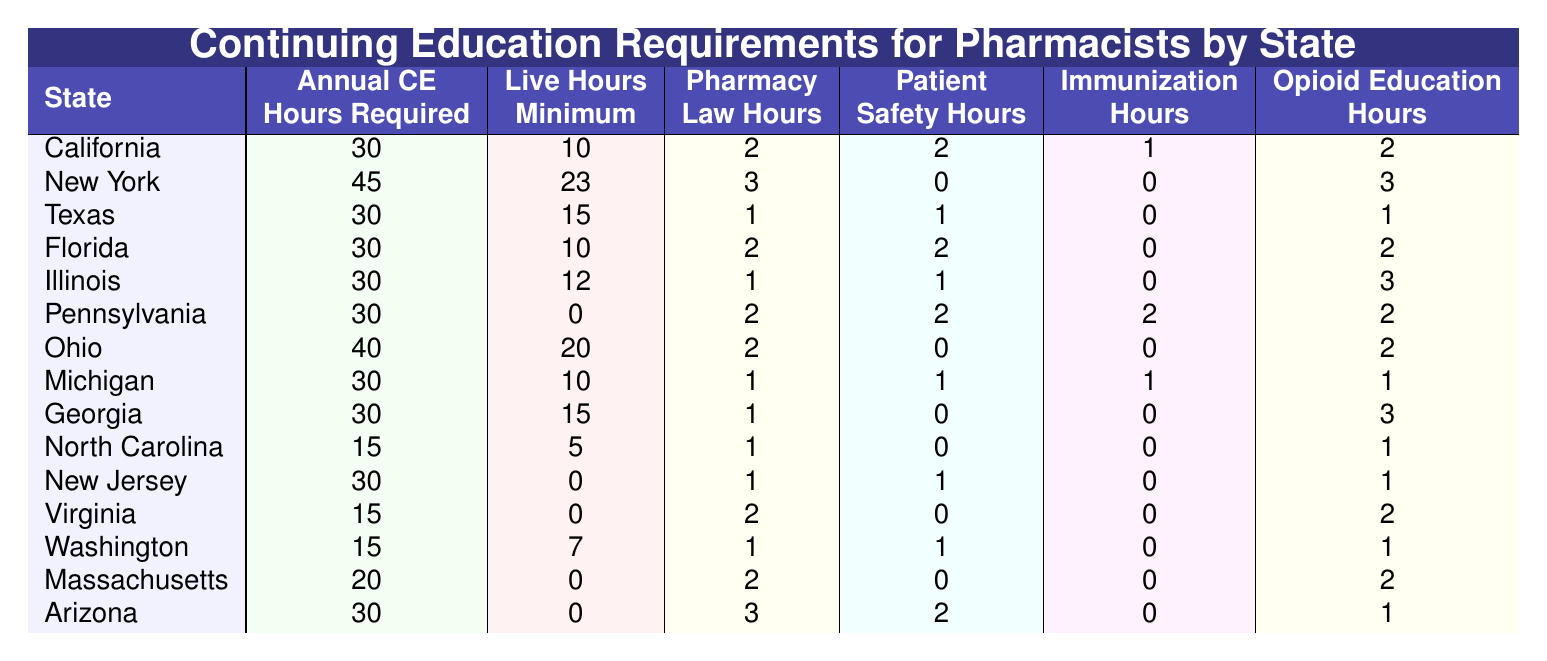What is the annual CE hours required for New York? The table shows that New York requires 45 annual CE hours.
Answer: 45 How many live hours are necessary for pharmacists in Texas? According to the table, Texas requires a minimum of 15 live hours.
Answer: 15 Which state has the highest annual CE hours requirement? By comparing the values, New York with 45 hours has the highest requirement.
Answer: New York Do both California and Texas require the same number of Pharmacy Law Hours? California requires 2 Pharmacy Law Hours while Texas requires only 1, so they do not require the same amount.
Answer: No How many total hours are required for continuing education in Pennsylvania when adding all specific area hours? Pennsylvania requires 30 total hours, with 2 for Pharmacy Law, 2 for Patient Safety, 2 for Immunization, and 2 for Opioid Education. So, 30 = 2 + 2 + 2 + 2 + other unspecified.
Answer: 30 Which state requires fewer annual CE hours: Virginia or North Carolina? Virginia requires 15 and North Carolina requires 15 as well; therefore, they have the same requirement.
Answer: Virginia and North Carolina are equal What is the average number of Immunization hours required across all states listed? The total Immunization hours across the states are 1 + 0 + 0 + 0 + 0 + 2 + 0 + 1 + 0 + 0 + 0 + 0 + 0 + 0 + 0 + 1 = 6. There are 15 states, so the average is 6/15 = 0.4.
Answer: 0.4 Which state has the lowest requirement for Opioid Education hours? The table shows North Carolina, Texas, Florida, and New Jersey all require 1 Opioid Education hour, which is the lowest.
Answer: North Carolina, Texas, Florida, and New Jersey Is there a state that requires live hours minimum lower than 5? North Carolina and Virginia both require 5 or fewer live hours minimum, thus they meet this condition.
Answer: Yes Compare the annual CE hours of California and Florida. Which one is greater? California requires 30 annual CE hours, and Florida also requires 30, so they have equal requirements.
Answer: Equal How many states require at least 30 live hours minimum? The states that require at least 30 live hours minimum are New York (23) and Ohio (20), totaling 2 states.
Answer: 2 